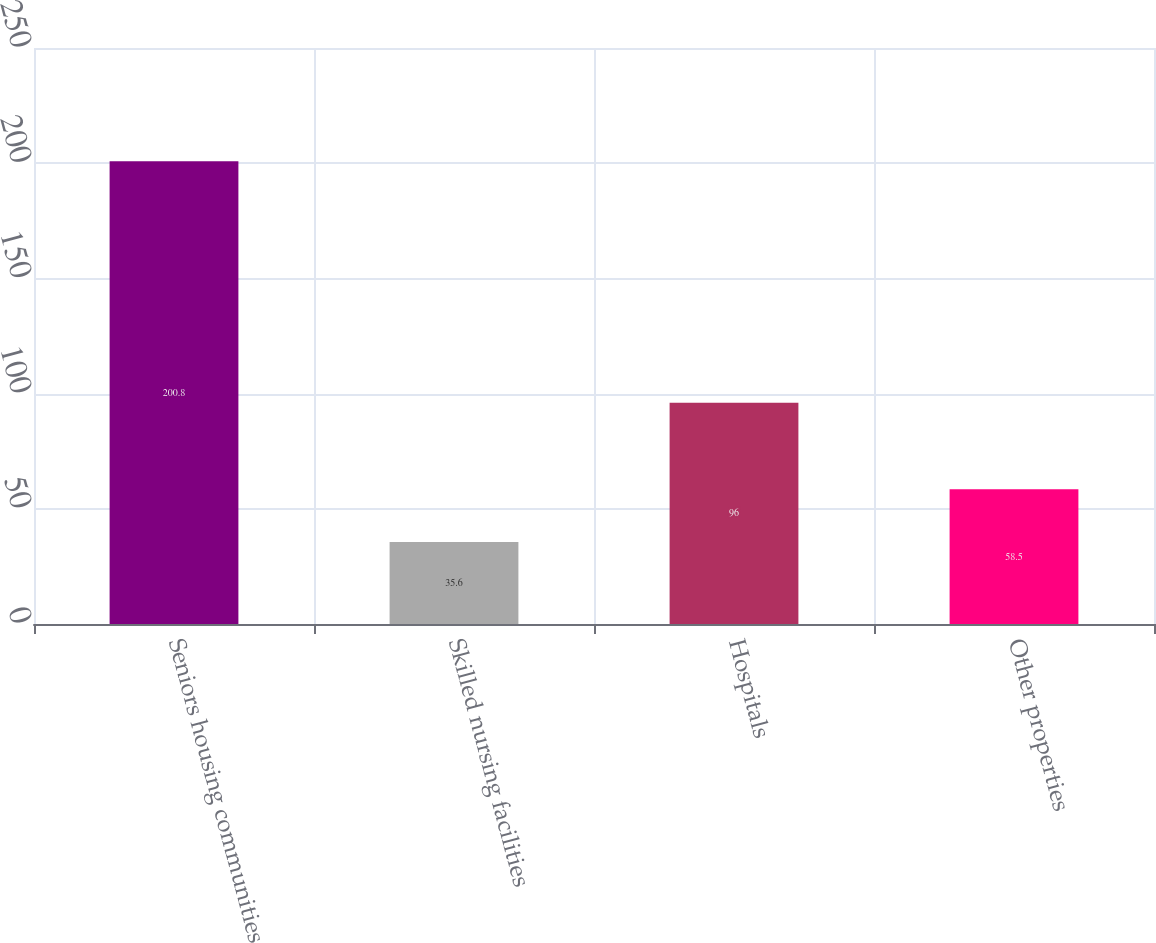Convert chart. <chart><loc_0><loc_0><loc_500><loc_500><bar_chart><fcel>Seniors housing communities<fcel>Skilled nursing facilities<fcel>Hospitals<fcel>Other properties<nl><fcel>200.8<fcel>35.6<fcel>96<fcel>58.5<nl></chart> 